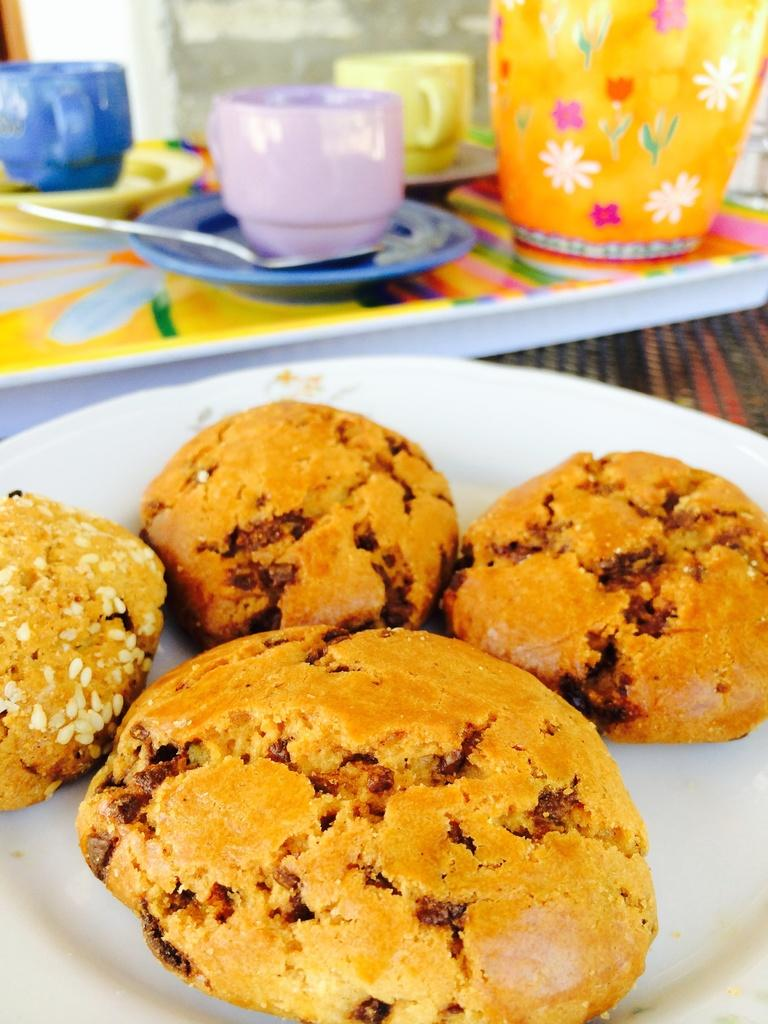What type of furniture is present in the image? There is a table in the image. How many plates are on the table? There are two plates on the table. What is on the first plate? The first plate contains cookies. What is on the second plate? The second plate contains cups, saucers, and a jug. How many circles can be seen on the plates in the image? There is no information about circles on the plates in the image. Is there a crate visible in the image? There is no crate present in the image. 